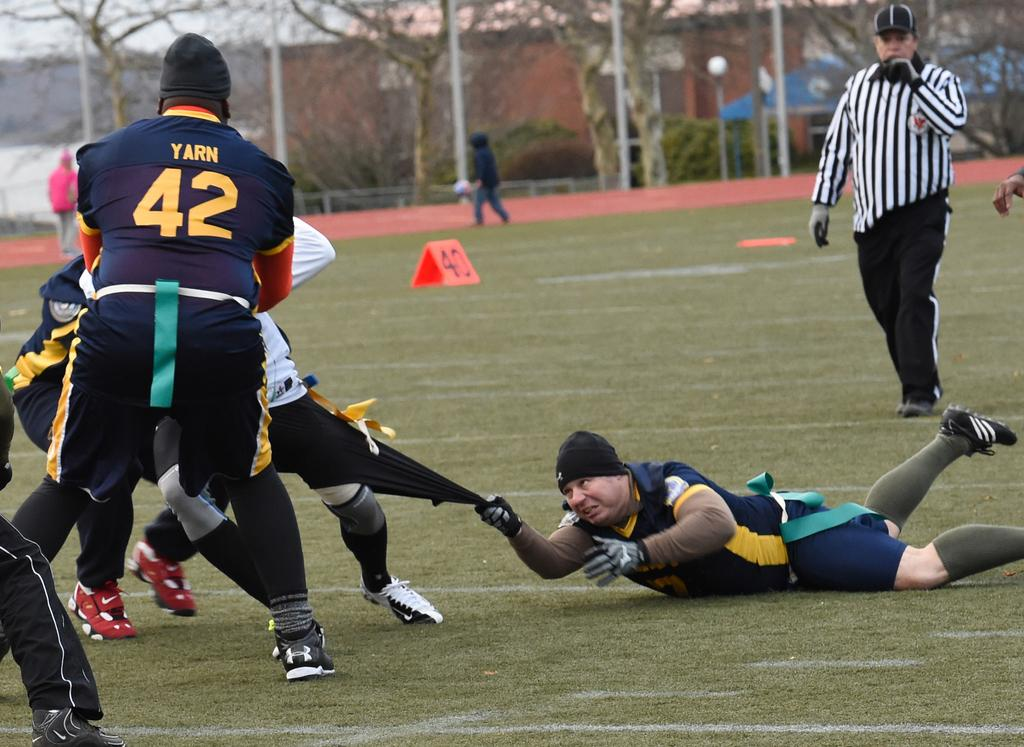How many people are in the image? There is a group of people in the image, but the exact number is not specified. What is the position of the people in the image? The people are on the ground in the image. What can be seen in the background of the image? In the background of the image, there are poles, trees, a building, a shed, a fence, and the sky. There are also some unspecified objects. Can you describe the setting of the image? The image appears to be set outdoors, with various structures and natural elements visible in the background. What type of berry is being used as a weapon in the image? There is no berry or weapon present in the image. How many pigs are visible in the image? There are no pigs visible in the image. 